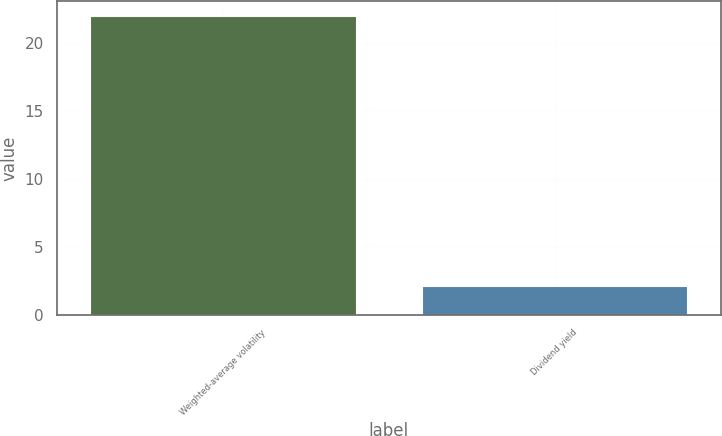Convert chart. <chart><loc_0><loc_0><loc_500><loc_500><bar_chart><fcel>Weighted-average volatility<fcel>Dividend yield<nl><fcel>22<fcel>2.1<nl></chart> 